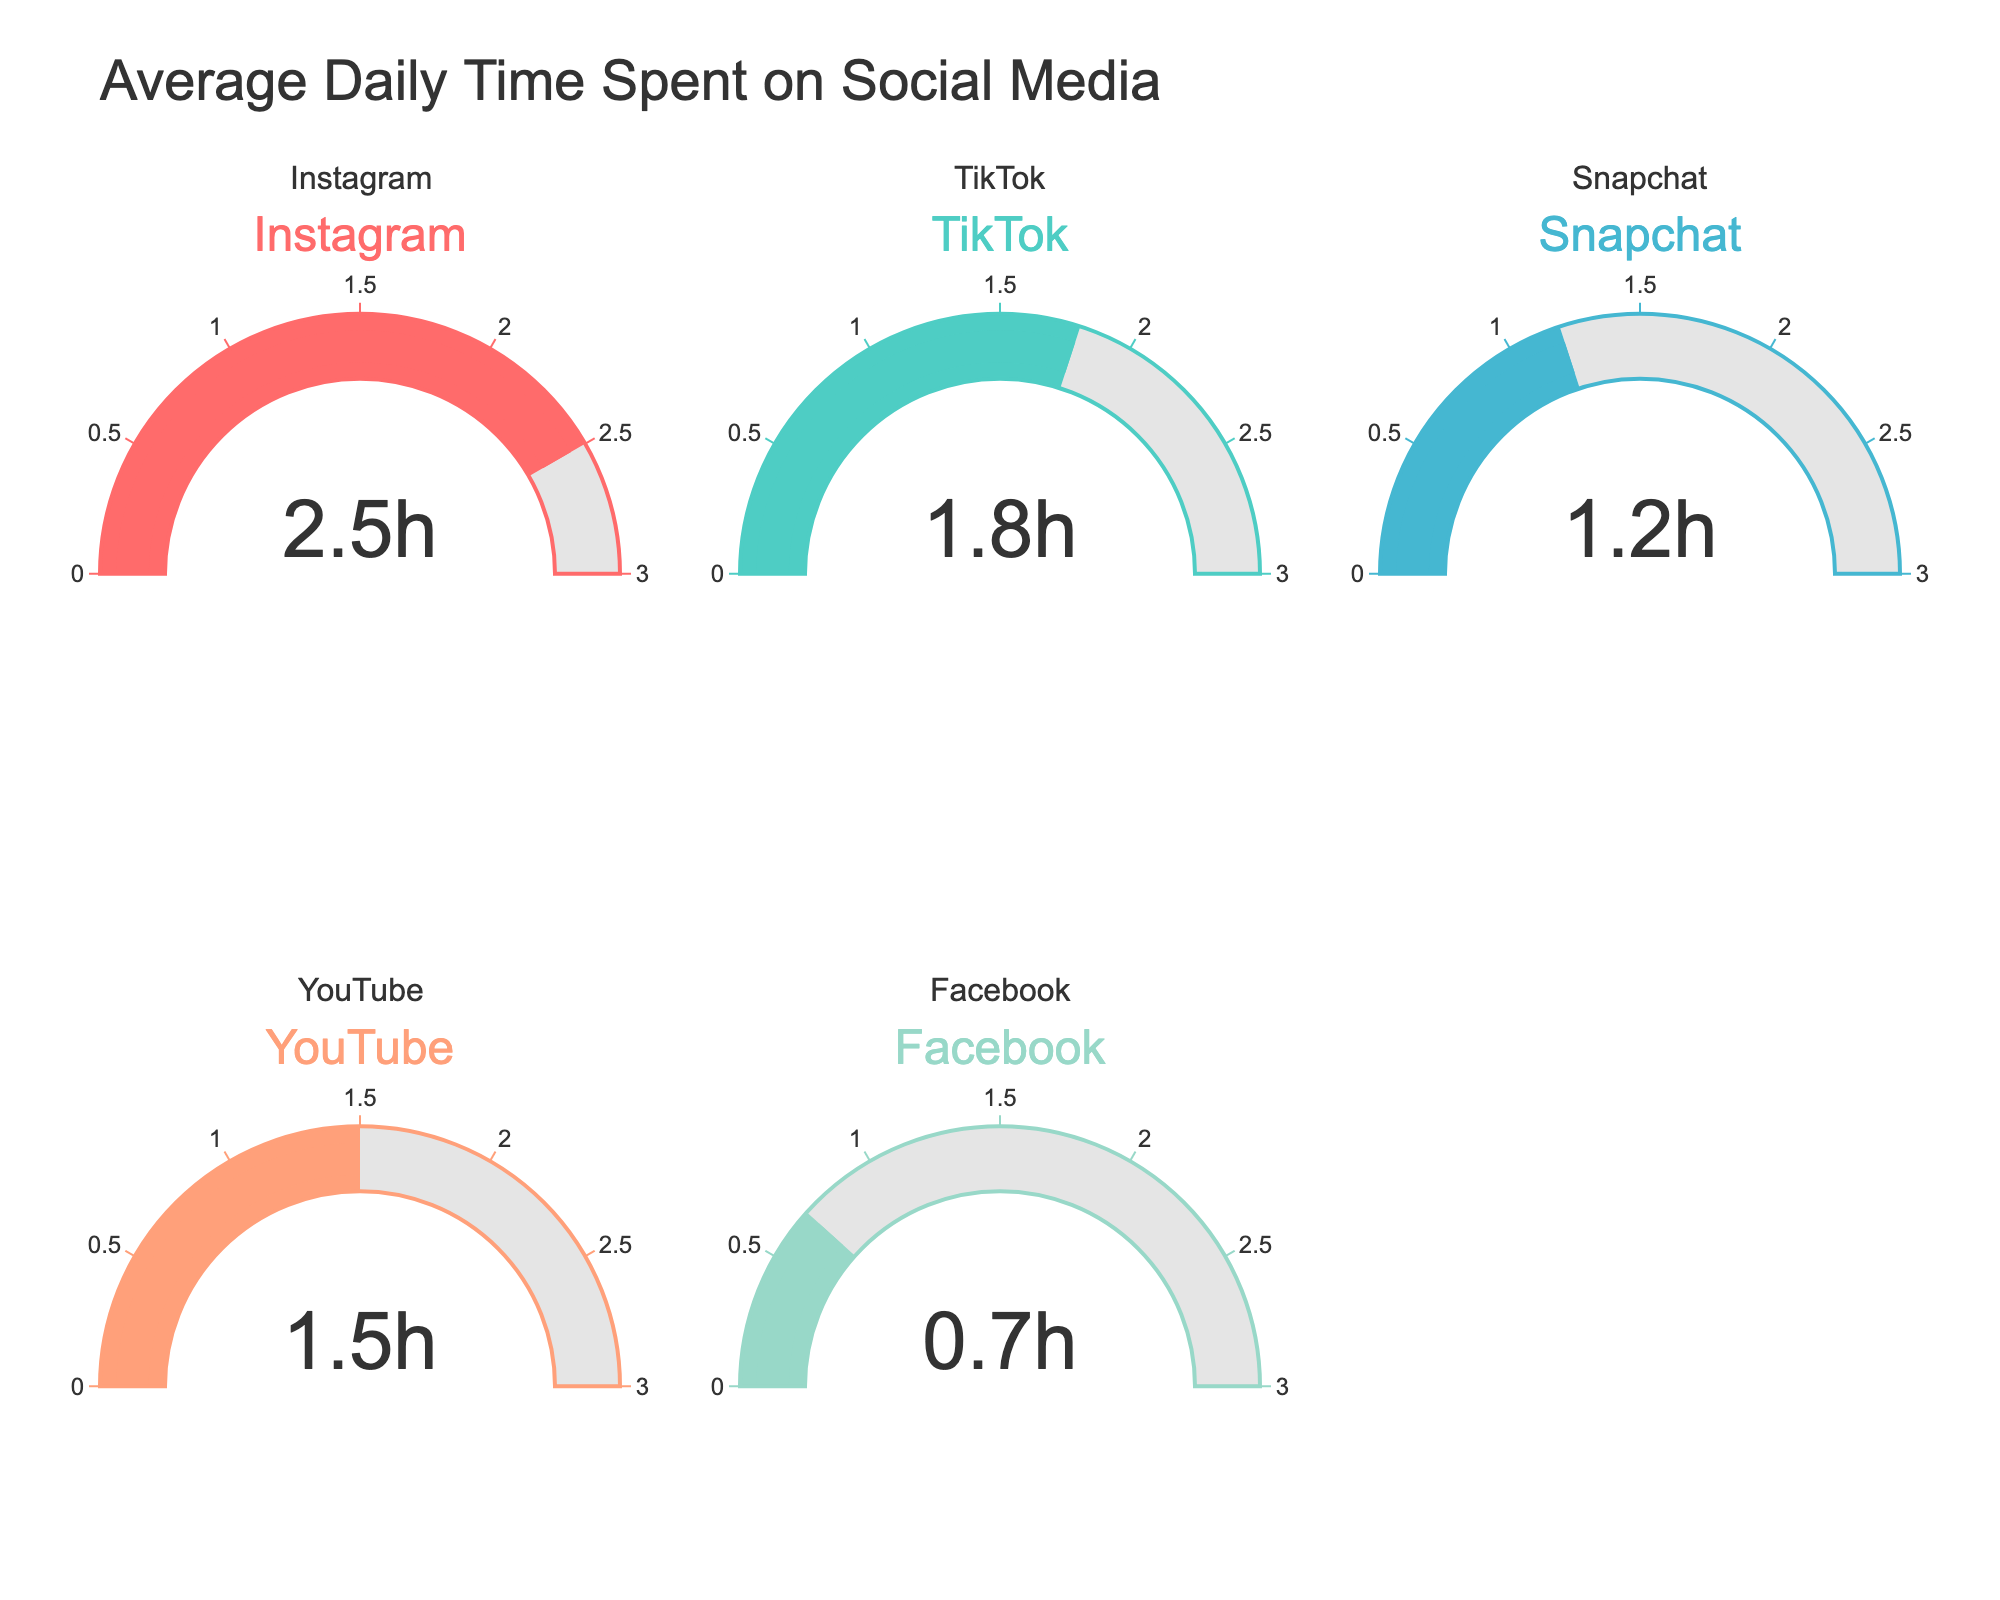Which social media platform has the highest average daily time spent? By looking at the values displayed in each gauge, Instagram shows the highest average daily time spent with 2.5 hours.
Answer: Instagram What is the total average daily time spent on the social media platforms displayed? Adding the average daily time spent on all these platforms: Instagram (2.5h) + TikTok (1.8h) + Snapchat (1.2h) + YouTube (1.5h) + Facebook (0.7h) = 7.7 hours.
Answer: 7.7 hours Which social media platform has the least average daily time spent? By looking at the values displayed in each gauge, Facebook shows the least average daily time spent with 0.7 hours.
Answer: Facebook How much more time is spent on Instagram daily compared to YouTube? The difference in daily time spent is calculated by subtracting the YouTube time from the Instagram time: 2.5 hours (Instagram) - 1.5 hours (YouTube) = 1 hour.
Answer: 1 hour Is the average daily time spent on TikTok greater than on Snapchat? By comparing the values, average daily time spent on TikTok (1.8h) is greater than on Snapchat (1.2h).
Answer: Yes Which platform is close to having an average of 1 hour of daily usage? Looking at the gauges, Facebook, with 0.7 hours, is the closest to 1 hour of daily usage.
Answer: Facebook What is the combined average daily time spent on YouTube and TikTok? Adding the average daily time spent on YouTube and TikTok: 1.5 hours (YouTube) + 1.8 hours (TikTok) = 3.3 hours.
Answer: 3.3 hours How many platforms have an average daily usage time of more than 1.5 hours? By reading the values on the gauges, Instagram (2.5h) and TikTok (1.8h) are the platforms with average daily usage time of more than 1.5 hours.
Answer: 2 platforms Which social media platform has a time value displayed in red on the gauge chart? By observing the colors corresponding to each platform, Instagram's gauge is displayed in red with 2.5 hours.
Answer: Instagram 